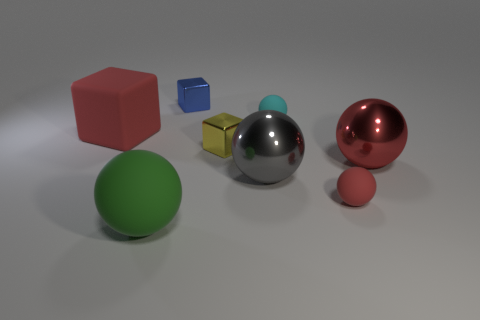Subtract 1 balls. How many balls are left? 4 Subtract all gray spheres. How many spheres are left? 4 Subtract all small cyan balls. How many balls are left? 4 Subtract all green spheres. Subtract all yellow cubes. How many spheres are left? 4 Add 2 big red matte things. How many objects exist? 10 Subtract all spheres. How many objects are left? 3 Subtract 0 purple blocks. How many objects are left? 8 Subtract all small matte objects. Subtract all red blocks. How many objects are left? 5 Add 4 tiny yellow shiny cubes. How many tiny yellow shiny cubes are left? 5 Add 6 small metallic cubes. How many small metallic cubes exist? 8 